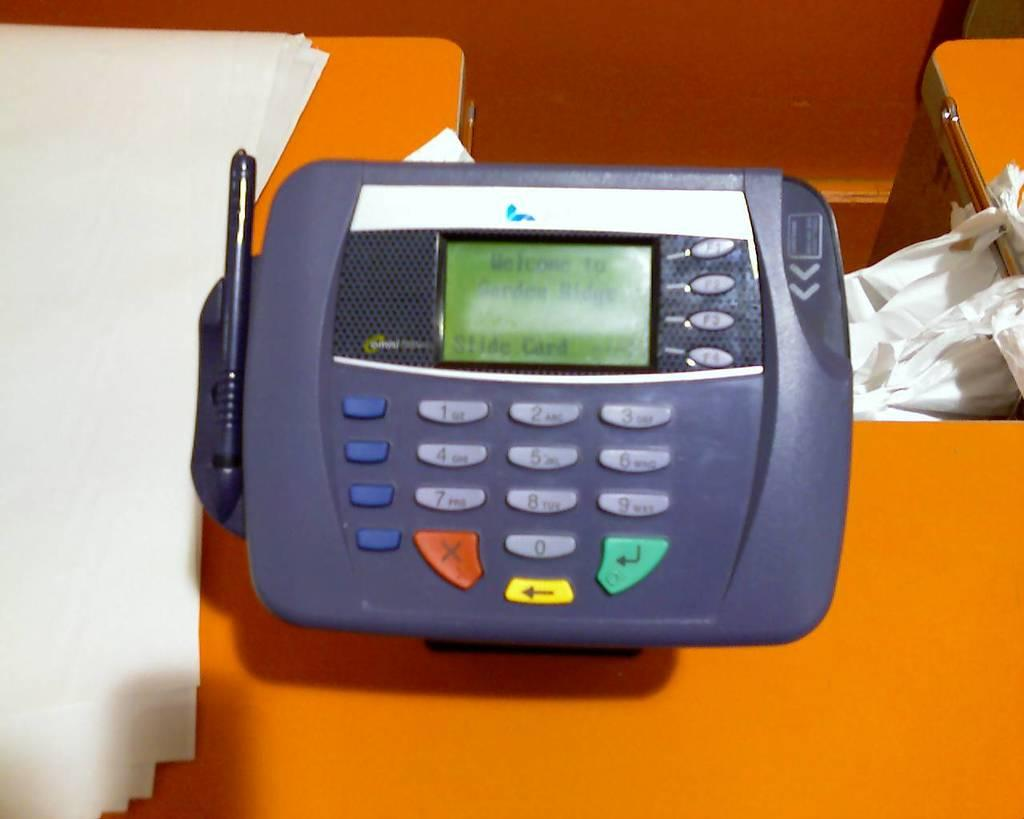What device is present in the image for processing card payments? There is a card swiping machine in the image. What else can be seen in the image besides the card swiping machine? There are papers in the image. How many dolls are sitting on the bikes in the image? There are no dolls or bikes present in the image; it only features a card swiping machine and papers. 